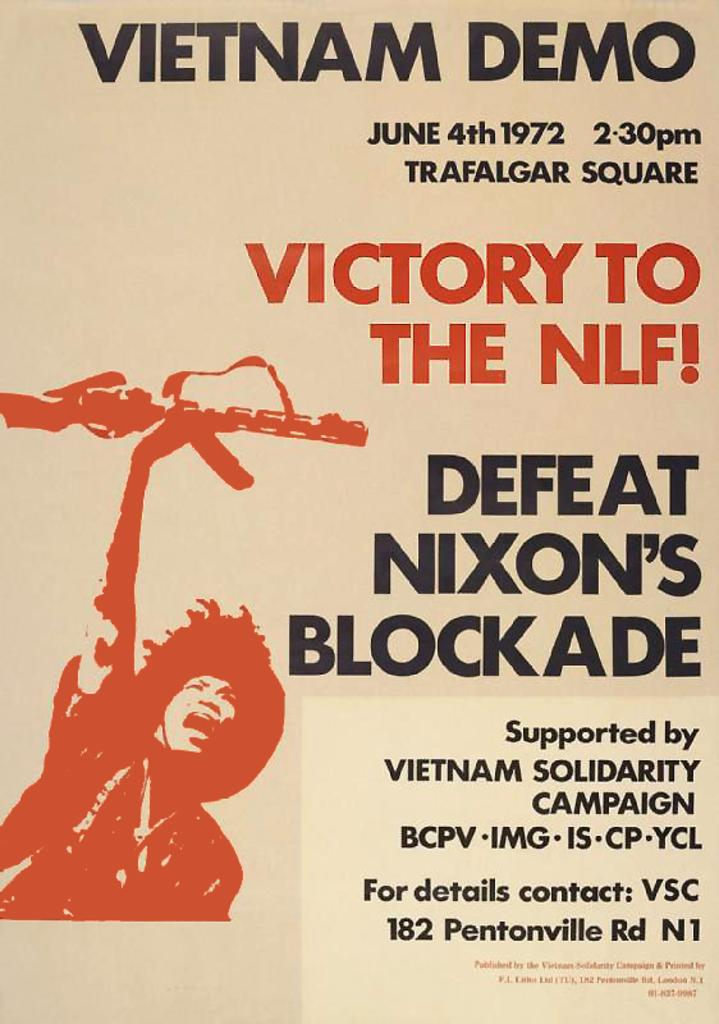<image>
Write a terse but informative summary of the picture. a poster that has a Vietnam Demo on it 